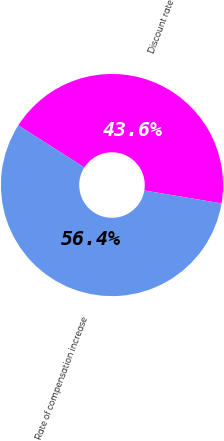Convert chart to OTSL. <chart><loc_0><loc_0><loc_500><loc_500><pie_chart><fcel>Discount rate<fcel>Rate of compensation increase<nl><fcel>43.62%<fcel>56.38%<nl></chart> 